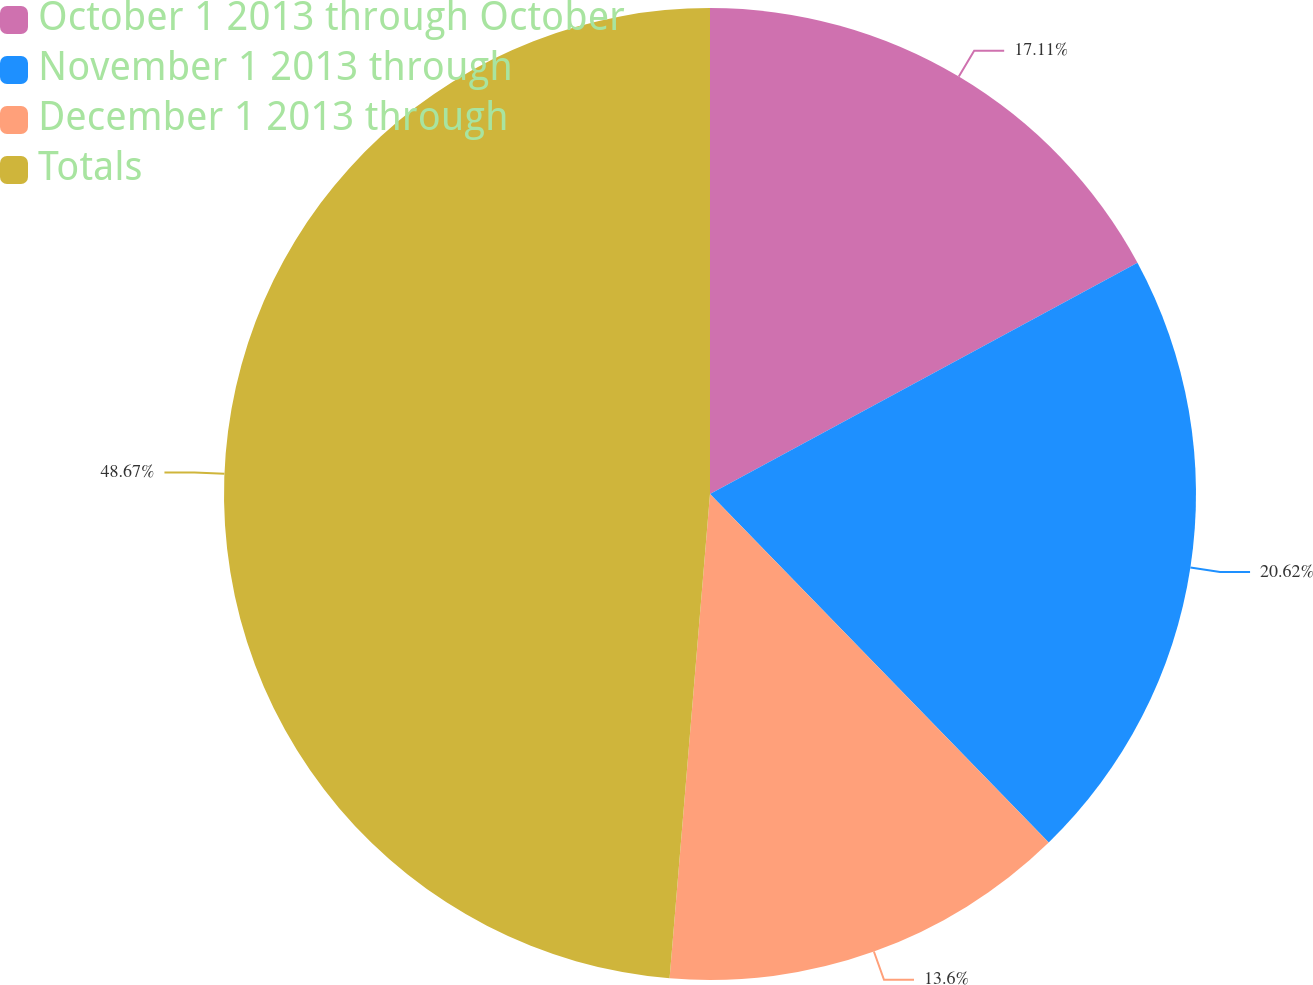Convert chart. <chart><loc_0><loc_0><loc_500><loc_500><pie_chart><fcel>October 1 2013 through October<fcel>November 1 2013 through<fcel>December 1 2013 through<fcel>Totals<nl><fcel>17.11%<fcel>20.62%<fcel>13.6%<fcel>48.68%<nl></chart> 